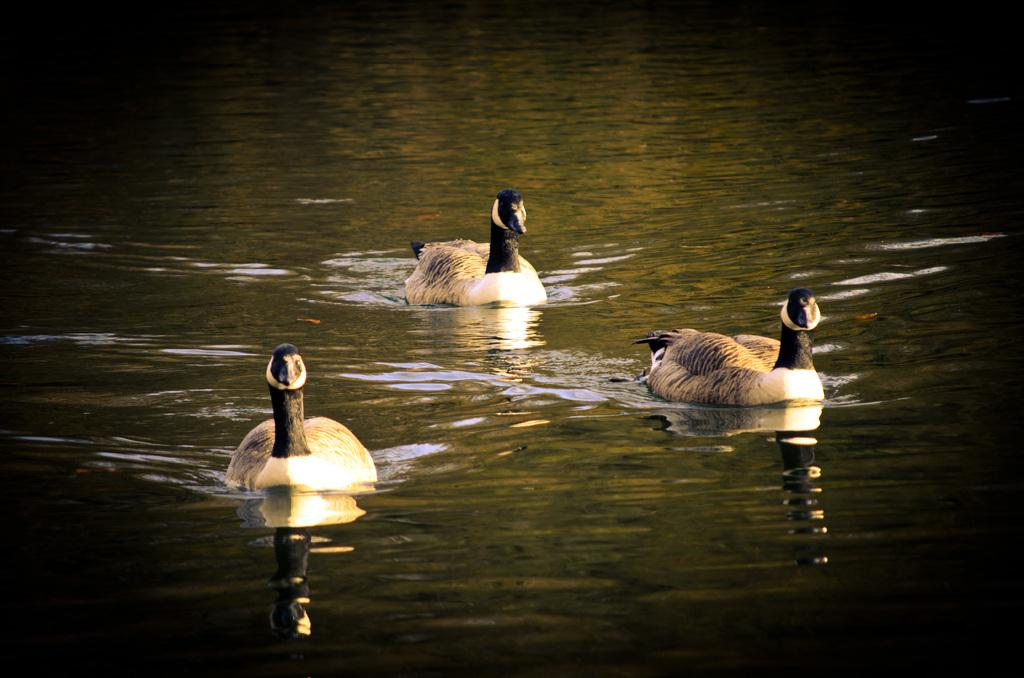How many ducks are present in the image? There are three ducks in the image. What are the ducks doing in the image? The ducks are swimming in the lake. What type of fog can be seen surrounding the ducks in the image? There is no fog present in the image; the ducks are swimming in a lake with clear visibility. 